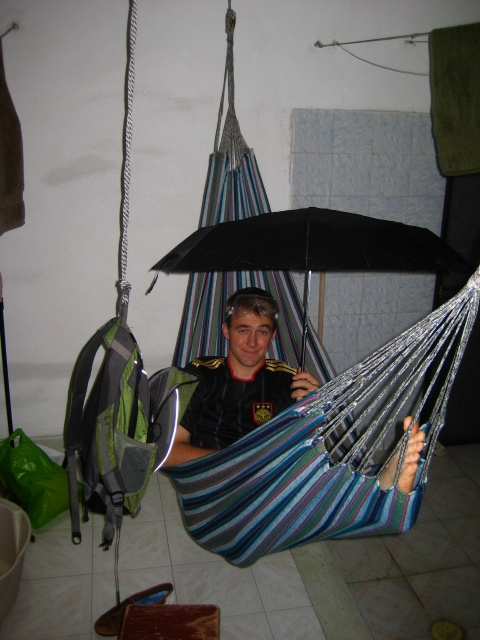Can you describe the decorations or style of the room in the image? The room has a simple, functional style with minimal decorations. The walls are plain, and there is a blue padded mat against one wall. The overall ambiance is quite utilitarian with no ornate furnishings or decorations. 